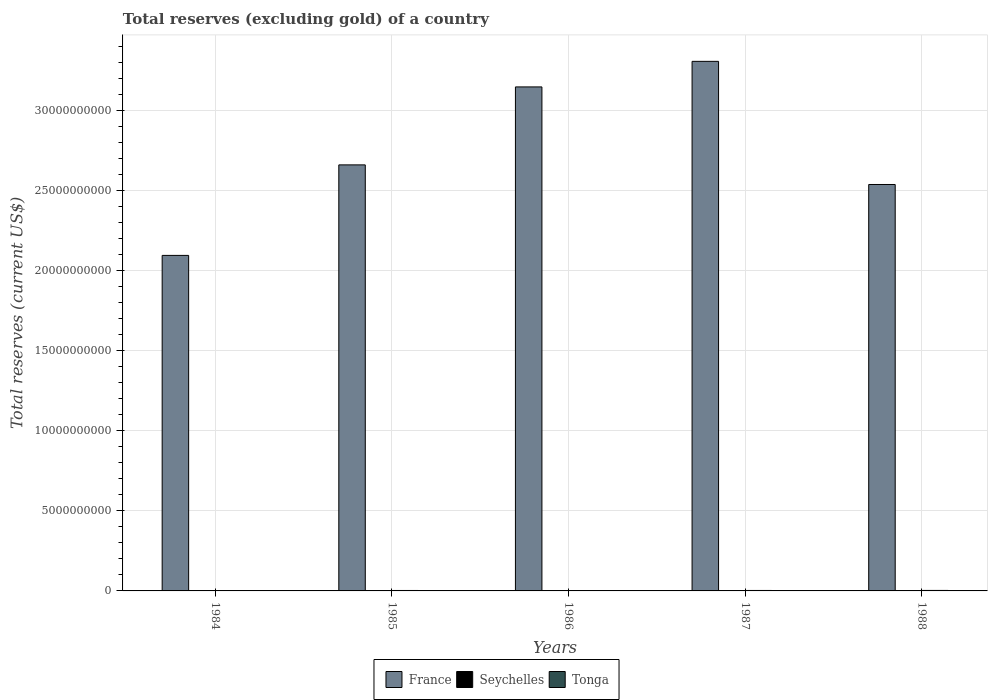How many different coloured bars are there?
Provide a succinct answer. 3. How many groups of bars are there?
Your answer should be compact. 5. Are the number of bars per tick equal to the number of legend labels?
Make the answer very short. Yes. Are the number of bars on each tick of the X-axis equal?
Ensure brevity in your answer.  Yes. How many bars are there on the 2nd tick from the left?
Your answer should be very brief. 3. How many bars are there on the 2nd tick from the right?
Your answer should be very brief. 3. In how many cases, is the number of bars for a given year not equal to the number of legend labels?
Your response must be concise. 0. What is the total reserves (excluding gold) in Tonga in 1985?
Give a very brief answer. 2.75e+07. Across all years, what is the maximum total reserves (excluding gold) in Tonga?
Offer a very short reply. 3.05e+07. Across all years, what is the minimum total reserves (excluding gold) in France?
Offer a very short reply. 2.09e+1. In which year was the total reserves (excluding gold) in Seychelles minimum?
Offer a terse response. 1984. What is the total total reserves (excluding gold) in Seychelles in the graph?
Give a very brief answer. 4.41e+07. What is the difference between the total reserves (excluding gold) in Tonga in 1985 and that in 1986?
Ensure brevity in your answer.  5.03e+06. What is the difference between the total reserves (excluding gold) in France in 1985 and the total reserves (excluding gold) in Tonga in 1984?
Make the answer very short. 2.66e+1. What is the average total reserves (excluding gold) in Seychelles per year?
Keep it short and to the point. 8.81e+06. In the year 1984, what is the difference between the total reserves (excluding gold) in Seychelles and total reserves (excluding gold) in Tonga?
Ensure brevity in your answer.  -2.06e+07. What is the ratio of the total reserves (excluding gold) in France in 1984 to that in 1988?
Give a very brief answer. 0.83. Is the total reserves (excluding gold) in Seychelles in 1985 less than that in 1988?
Your answer should be compact. Yes. Is the difference between the total reserves (excluding gold) in Seychelles in 1985 and 1986 greater than the difference between the total reserves (excluding gold) in Tonga in 1985 and 1986?
Ensure brevity in your answer.  No. What is the difference between the highest and the second highest total reserves (excluding gold) in Seychelles?
Offer a terse response. 5.01e+06. What is the difference between the highest and the lowest total reserves (excluding gold) in France?
Provide a succinct answer. 1.21e+1. In how many years, is the total reserves (excluding gold) in Seychelles greater than the average total reserves (excluding gold) in Seychelles taken over all years?
Your answer should be very brief. 1. What does the 3rd bar from the left in 1986 represents?
Offer a very short reply. Tonga. What does the 1st bar from the right in 1984 represents?
Your answer should be very brief. Tonga. Are all the bars in the graph horizontal?
Make the answer very short. No. Are the values on the major ticks of Y-axis written in scientific E-notation?
Your answer should be very brief. No. Does the graph contain any zero values?
Provide a short and direct response. No. Does the graph contain grids?
Your answer should be compact. Yes. Where does the legend appear in the graph?
Your answer should be very brief. Bottom center. How are the legend labels stacked?
Your answer should be very brief. Horizontal. What is the title of the graph?
Give a very brief answer. Total reserves (excluding gold) of a country. Does "Cyprus" appear as one of the legend labels in the graph?
Offer a terse response. No. What is the label or title of the Y-axis?
Keep it short and to the point. Total reserves (current US$). What is the Total reserves (current US$) of France in 1984?
Give a very brief answer. 2.09e+1. What is the Total reserves (current US$) in Seychelles in 1984?
Keep it short and to the point. 5.40e+06. What is the Total reserves (current US$) of Tonga in 1984?
Your answer should be compact. 2.60e+07. What is the Total reserves (current US$) of France in 1985?
Keep it short and to the point. 2.66e+1. What is the Total reserves (current US$) of Seychelles in 1985?
Ensure brevity in your answer.  8.50e+06. What is the Total reserves (current US$) in Tonga in 1985?
Your response must be concise. 2.75e+07. What is the Total reserves (current US$) of France in 1986?
Your answer should be compact. 3.15e+1. What is the Total reserves (current US$) in Seychelles in 1986?
Give a very brief answer. 7.75e+06. What is the Total reserves (current US$) of Tonga in 1986?
Keep it short and to the point. 2.25e+07. What is the Total reserves (current US$) in France in 1987?
Ensure brevity in your answer.  3.30e+1. What is the Total reserves (current US$) in Seychelles in 1987?
Your answer should be very brief. 1.37e+07. What is the Total reserves (current US$) in Tonga in 1987?
Provide a succinct answer. 2.89e+07. What is the Total reserves (current US$) in France in 1988?
Your answer should be very brief. 2.54e+1. What is the Total reserves (current US$) in Seychelles in 1988?
Offer a terse response. 8.71e+06. What is the Total reserves (current US$) in Tonga in 1988?
Make the answer very short. 3.05e+07. Across all years, what is the maximum Total reserves (current US$) in France?
Ensure brevity in your answer.  3.30e+1. Across all years, what is the maximum Total reserves (current US$) in Seychelles?
Make the answer very short. 1.37e+07. Across all years, what is the maximum Total reserves (current US$) in Tonga?
Offer a very short reply. 3.05e+07. Across all years, what is the minimum Total reserves (current US$) of France?
Your answer should be very brief. 2.09e+1. Across all years, what is the minimum Total reserves (current US$) in Seychelles?
Ensure brevity in your answer.  5.40e+06. Across all years, what is the minimum Total reserves (current US$) in Tonga?
Make the answer very short. 2.25e+07. What is the total Total reserves (current US$) in France in the graph?
Provide a succinct answer. 1.37e+11. What is the total Total reserves (current US$) in Seychelles in the graph?
Offer a very short reply. 4.41e+07. What is the total Total reserves (current US$) in Tonga in the graph?
Your answer should be compact. 1.35e+08. What is the difference between the Total reserves (current US$) in France in 1984 and that in 1985?
Make the answer very short. -5.65e+09. What is the difference between the Total reserves (current US$) in Seychelles in 1984 and that in 1985?
Ensure brevity in your answer.  -3.10e+06. What is the difference between the Total reserves (current US$) in Tonga in 1984 and that in 1985?
Provide a short and direct response. -1.49e+06. What is the difference between the Total reserves (current US$) in France in 1984 and that in 1986?
Offer a very short reply. -1.05e+1. What is the difference between the Total reserves (current US$) in Seychelles in 1984 and that in 1986?
Provide a succinct answer. -2.35e+06. What is the difference between the Total reserves (current US$) of Tonga in 1984 and that in 1986?
Provide a succinct answer. 3.54e+06. What is the difference between the Total reserves (current US$) in France in 1984 and that in 1987?
Offer a very short reply. -1.21e+1. What is the difference between the Total reserves (current US$) of Seychelles in 1984 and that in 1987?
Ensure brevity in your answer.  -8.31e+06. What is the difference between the Total reserves (current US$) of Tonga in 1984 and that in 1987?
Offer a very short reply. -2.86e+06. What is the difference between the Total reserves (current US$) in France in 1984 and that in 1988?
Provide a succinct answer. -4.42e+09. What is the difference between the Total reserves (current US$) of Seychelles in 1984 and that in 1988?
Your response must be concise. -3.31e+06. What is the difference between the Total reserves (current US$) in Tonga in 1984 and that in 1988?
Offer a terse response. -4.49e+06. What is the difference between the Total reserves (current US$) in France in 1985 and that in 1986?
Make the answer very short. -4.87e+09. What is the difference between the Total reserves (current US$) of Seychelles in 1985 and that in 1986?
Your response must be concise. 7.52e+05. What is the difference between the Total reserves (current US$) in Tonga in 1985 and that in 1986?
Offer a terse response. 5.03e+06. What is the difference between the Total reserves (current US$) in France in 1985 and that in 1987?
Your response must be concise. -6.46e+09. What is the difference between the Total reserves (current US$) in Seychelles in 1985 and that in 1987?
Ensure brevity in your answer.  -5.21e+06. What is the difference between the Total reserves (current US$) of Tonga in 1985 and that in 1987?
Offer a very short reply. -1.37e+06. What is the difference between the Total reserves (current US$) in France in 1985 and that in 1988?
Your response must be concise. 1.22e+09. What is the difference between the Total reserves (current US$) of Seychelles in 1985 and that in 1988?
Provide a short and direct response. -2.06e+05. What is the difference between the Total reserves (current US$) of Tonga in 1985 and that in 1988?
Provide a short and direct response. -3.00e+06. What is the difference between the Total reserves (current US$) of France in 1986 and that in 1987?
Ensure brevity in your answer.  -1.60e+09. What is the difference between the Total reserves (current US$) of Seychelles in 1986 and that in 1987?
Offer a very short reply. -5.96e+06. What is the difference between the Total reserves (current US$) of Tonga in 1986 and that in 1987?
Ensure brevity in your answer.  -6.40e+06. What is the difference between the Total reserves (current US$) of France in 1986 and that in 1988?
Offer a terse response. 6.09e+09. What is the difference between the Total reserves (current US$) in Seychelles in 1986 and that in 1988?
Keep it short and to the point. -9.58e+05. What is the difference between the Total reserves (current US$) of Tonga in 1986 and that in 1988?
Ensure brevity in your answer.  -8.03e+06. What is the difference between the Total reserves (current US$) of France in 1987 and that in 1988?
Give a very brief answer. 7.68e+09. What is the difference between the Total reserves (current US$) of Seychelles in 1987 and that in 1988?
Give a very brief answer. 5.01e+06. What is the difference between the Total reserves (current US$) in Tonga in 1987 and that in 1988?
Your answer should be very brief. -1.63e+06. What is the difference between the Total reserves (current US$) in France in 1984 and the Total reserves (current US$) in Seychelles in 1985?
Your response must be concise. 2.09e+1. What is the difference between the Total reserves (current US$) in France in 1984 and the Total reserves (current US$) in Tonga in 1985?
Offer a terse response. 2.09e+1. What is the difference between the Total reserves (current US$) of Seychelles in 1984 and the Total reserves (current US$) of Tonga in 1985?
Provide a short and direct response. -2.21e+07. What is the difference between the Total reserves (current US$) in France in 1984 and the Total reserves (current US$) in Seychelles in 1986?
Your answer should be very brief. 2.09e+1. What is the difference between the Total reserves (current US$) of France in 1984 and the Total reserves (current US$) of Tonga in 1986?
Make the answer very short. 2.09e+1. What is the difference between the Total reserves (current US$) of Seychelles in 1984 and the Total reserves (current US$) of Tonga in 1986?
Keep it short and to the point. -1.71e+07. What is the difference between the Total reserves (current US$) of France in 1984 and the Total reserves (current US$) of Seychelles in 1987?
Your answer should be compact. 2.09e+1. What is the difference between the Total reserves (current US$) of France in 1984 and the Total reserves (current US$) of Tonga in 1987?
Make the answer very short. 2.09e+1. What is the difference between the Total reserves (current US$) of Seychelles in 1984 and the Total reserves (current US$) of Tonga in 1987?
Your answer should be very brief. -2.35e+07. What is the difference between the Total reserves (current US$) in France in 1984 and the Total reserves (current US$) in Seychelles in 1988?
Offer a very short reply. 2.09e+1. What is the difference between the Total reserves (current US$) of France in 1984 and the Total reserves (current US$) of Tonga in 1988?
Keep it short and to the point. 2.09e+1. What is the difference between the Total reserves (current US$) in Seychelles in 1984 and the Total reserves (current US$) in Tonga in 1988?
Provide a short and direct response. -2.51e+07. What is the difference between the Total reserves (current US$) of France in 1985 and the Total reserves (current US$) of Seychelles in 1986?
Your response must be concise. 2.66e+1. What is the difference between the Total reserves (current US$) in France in 1985 and the Total reserves (current US$) in Tonga in 1986?
Your answer should be compact. 2.66e+1. What is the difference between the Total reserves (current US$) in Seychelles in 1985 and the Total reserves (current US$) in Tonga in 1986?
Your answer should be very brief. -1.40e+07. What is the difference between the Total reserves (current US$) of France in 1985 and the Total reserves (current US$) of Seychelles in 1987?
Your answer should be compact. 2.66e+1. What is the difference between the Total reserves (current US$) in France in 1985 and the Total reserves (current US$) in Tonga in 1987?
Keep it short and to the point. 2.66e+1. What is the difference between the Total reserves (current US$) of Seychelles in 1985 and the Total reserves (current US$) of Tonga in 1987?
Your response must be concise. -2.04e+07. What is the difference between the Total reserves (current US$) of France in 1985 and the Total reserves (current US$) of Seychelles in 1988?
Provide a succinct answer. 2.66e+1. What is the difference between the Total reserves (current US$) in France in 1985 and the Total reserves (current US$) in Tonga in 1988?
Provide a short and direct response. 2.66e+1. What is the difference between the Total reserves (current US$) in Seychelles in 1985 and the Total reserves (current US$) in Tonga in 1988?
Make the answer very short. -2.20e+07. What is the difference between the Total reserves (current US$) of France in 1986 and the Total reserves (current US$) of Seychelles in 1987?
Ensure brevity in your answer.  3.14e+1. What is the difference between the Total reserves (current US$) in France in 1986 and the Total reserves (current US$) in Tonga in 1987?
Offer a very short reply. 3.14e+1. What is the difference between the Total reserves (current US$) in Seychelles in 1986 and the Total reserves (current US$) in Tonga in 1987?
Ensure brevity in your answer.  -2.11e+07. What is the difference between the Total reserves (current US$) of France in 1986 and the Total reserves (current US$) of Seychelles in 1988?
Offer a terse response. 3.14e+1. What is the difference between the Total reserves (current US$) of France in 1986 and the Total reserves (current US$) of Tonga in 1988?
Make the answer very short. 3.14e+1. What is the difference between the Total reserves (current US$) of Seychelles in 1986 and the Total reserves (current US$) of Tonga in 1988?
Provide a succinct answer. -2.28e+07. What is the difference between the Total reserves (current US$) of France in 1987 and the Total reserves (current US$) of Seychelles in 1988?
Your response must be concise. 3.30e+1. What is the difference between the Total reserves (current US$) in France in 1987 and the Total reserves (current US$) in Tonga in 1988?
Offer a terse response. 3.30e+1. What is the difference between the Total reserves (current US$) of Seychelles in 1987 and the Total reserves (current US$) of Tonga in 1988?
Offer a very short reply. -1.68e+07. What is the average Total reserves (current US$) in France per year?
Provide a succinct answer. 2.75e+1. What is the average Total reserves (current US$) in Seychelles per year?
Give a very brief answer. 8.81e+06. What is the average Total reserves (current US$) in Tonga per year?
Keep it short and to the point. 2.71e+07. In the year 1984, what is the difference between the Total reserves (current US$) in France and Total reserves (current US$) in Seychelles?
Provide a succinct answer. 2.09e+1. In the year 1984, what is the difference between the Total reserves (current US$) of France and Total reserves (current US$) of Tonga?
Offer a very short reply. 2.09e+1. In the year 1984, what is the difference between the Total reserves (current US$) in Seychelles and Total reserves (current US$) in Tonga?
Ensure brevity in your answer.  -2.06e+07. In the year 1985, what is the difference between the Total reserves (current US$) in France and Total reserves (current US$) in Seychelles?
Make the answer very short. 2.66e+1. In the year 1985, what is the difference between the Total reserves (current US$) of France and Total reserves (current US$) of Tonga?
Keep it short and to the point. 2.66e+1. In the year 1985, what is the difference between the Total reserves (current US$) in Seychelles and Total reserves (current US$) in Tonga?
Ensure brevity in your answer.  -1.90e+07. In the year 1986, what is the difference between the Total reserves (current US$) of France and Total reserves (current US$) of Seychelles?
Your response must be concise. 3.14e+1. In the year 1986, what is the difference between the Total reserves (current US$) in France and Total reserves (current US$) in Tonga?
Give a very brief answer. 3.14e+1. In the year 1986, what is the difference between the Total reserves (current US$) in Seychelles and Total reserves (current US$) in Tonga?
Offer a very short reply. -1.47e+07. In the year 1987, what is the difference between the Total reserves (current US$) of France and Total reserves (current US$) of Seychelles?
Your response must be concise. 3.30e+1. In the year 1987, what is the difference between the Total reserves (current US$) of France and Total reserves (current US$) of Tonga?
Offer a terse response. 3.30e+1. In the year 1987, what is the difference between the Total reserves (current US$) in Seychelles and Total reserves (current US$) in Tonga?
Your response must be concise. -1.52e+07. In the year 1988, what is the difference between the Total reserves (current US$) in France and Total reserves (current US$) in Seychelles?
Your response must be concise. 2.54e+1. In the year 1988, what is the difference between the Total reserves (current US$) in France and Total reserves (current US$) in Tonga?
Give a very brief answer. 2.53e+1. In the year 1988, what is the difference between the Total reserves (current US$) in Seychelles and Total reserves (current US$) in Tonga?
Offer a very short reply. -2.18e+07. What is the ratio of the Total reserves (current US$) of France in 1984 to that in 1985?
Provide a succinct answer. 0.79. What is the ratio of the Total reserves (current US$) in Seychelles in 1984 to that in 1985?
Your answer should be very brief. 0.64. What is the ratio of the Total reserves (current US$) in Tonga in 1984 to that in 1985?
Offer a terse response. 0.95. What is the ratio of the Total reserves (current US$) in France in 1984 to that in 1986?
Provide a short and direct response. 0.67. What is the ratio of the Total reserves (current US$) in Seychelles in 1984 to that in 1986?
Your answer should be compact. 0.7. What is the ratio of the Total reserves (current US$) in Tonga in 1984 to that in 1986?
Your answer should be compact. 1.16. What is the ratio of the Total reserves (current US$) of France in 1984 to that in 1987?
Ensure brevity in your answer.  0.63. What is the ratio of the Total reserves (current US$) of Seychelles in 1984 to that in 1987?
Give a very brief answer. 0.39. What is the ratio of the Total reserves (current US$) of Tonga in 1984 to that in 1987?
Offer a very short reply. 0.9. What is the ratio of the Total reserves (current US$) of France in 1984 to that in 1988?
Make the answer very short. 0.83. What is the ratio of the Total reserves (current US$) in Seychelles in 1984 to that in 1988?
Your answer should be compact. 0.62. What is the ratio of the Total reserves (current US$) of Tonga in 1984 to that in 1988?
Ensure brevity in your answer.  0.85. What is the ratio of the Total reserves (current US$) of France in 1985 to that in 1986?
Offer a terse response. 0.85. What is the ratio of the Total reserves (current US$) of Seychelles in 1985 to that in 1986?
Your answer should be compact. 1.1. What is the ratio of the Total reserves (current US$) in Tonga in 1985 to that in 1986?
Offer a terse response. 1.22. What is the ratio of the Total reserves (current US$) of France in 1985 to that in 1987?
Offer a very short reply. 0.8. What is the ratio of the Total reserves (current US$) of Seychelles in 1985 to that in 1987?
Give a very brief answer. 0.62. What is the ratio of the Total reserves (current US$) of Tonga in 1985 to that in 1987?
Your answer should be very brief. 0.95. What is the ratio of the Total reserves (current US$) in France in 1985 to that in 1988?
Make the answer very short. 1.05. What is the ratio of the Total reserves (current US$) in Seychelles in 1985 to that in 1988?
Your response must be concise. 0.98. What is the ratio of the Total reserves (current US$) in Tonga in 1985 to that in 1988?
Your response must be concise. 0.9. What is the ratio of the Total reserves (current US$) of France in 1986 to that in 1987?
Provide a short and direct response. 0.95. What is the ratio of the Total reserves (current US$) of Seychelles in 1986 to that in 1987?
Provide a short and direct response. 0.57. What is the ratio of the Total reserves (current US$) of Tonga in 1986 to that in 1987?
Make the answer very short. 0.78. What is the ratio of the Total reserves (current US$) of France in 1986 to that in 1988?
Offer a terse response. 1.24. What is the ratio of the Total reserves (current US$) of Seychelles in 1986 to that in 1988?
Offer a very short reply. 0.89. What is the ratio of the Total reserves (current US$) of Tonga in 1986 to that in 1988?
Your answer should be compact. 0.74. What is the ratio of the Total reserves (current US$) of France in 1987 to that in 1988?
Make the answer very short. 1.3. What is the ratio of the Total reserves (current US$) in Seychelles in 1987 to that in 1988?
Your response must be concise. 1.57. What is the ratio of the Total reserves (current US$) in Tonga in 1987 to that in 1988?
Your answer should be compact. 0.95. What is the difference between the highest and the second highest Total reserves (current US$) of France?
Make the answer very short. 1.60e+09. What is the difference between the highest and the second highest Total reserves (current US$) of Seychelles?
Your answer should be compact. 5.01e+06. What is the difference between the highest and the second highest Total reserves (current US$) of Tonga?
Provide a short and direct response. 1.63e+06. What is the difference between the highest and the lowest Total reserves (current US$) of France?
Give a very brief answer. 1.21e+1. What is the difference between the highest and the lowest Total reserves (current US$) in Seychelles?
Your answer should be compact. 8.31e+06. What is the difference between the highest and the lowest Total reserves (current US$) of Tonga?
Your answer should be very brief. 8.03e+06. 